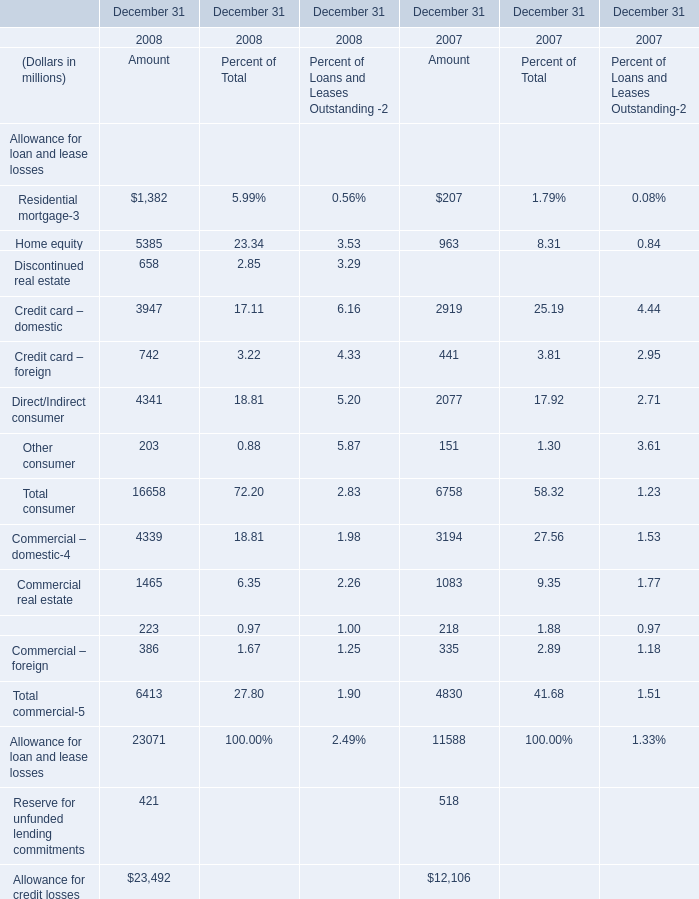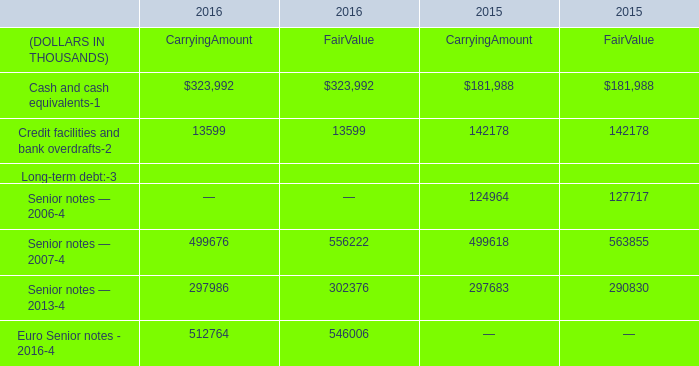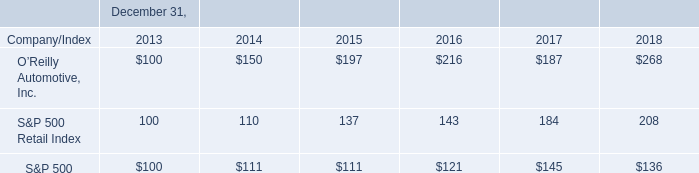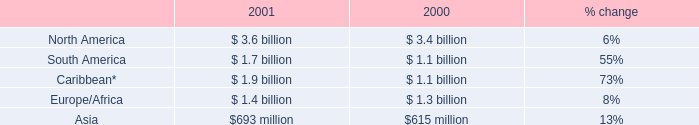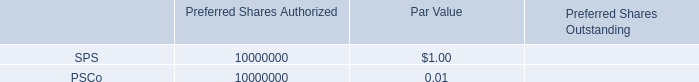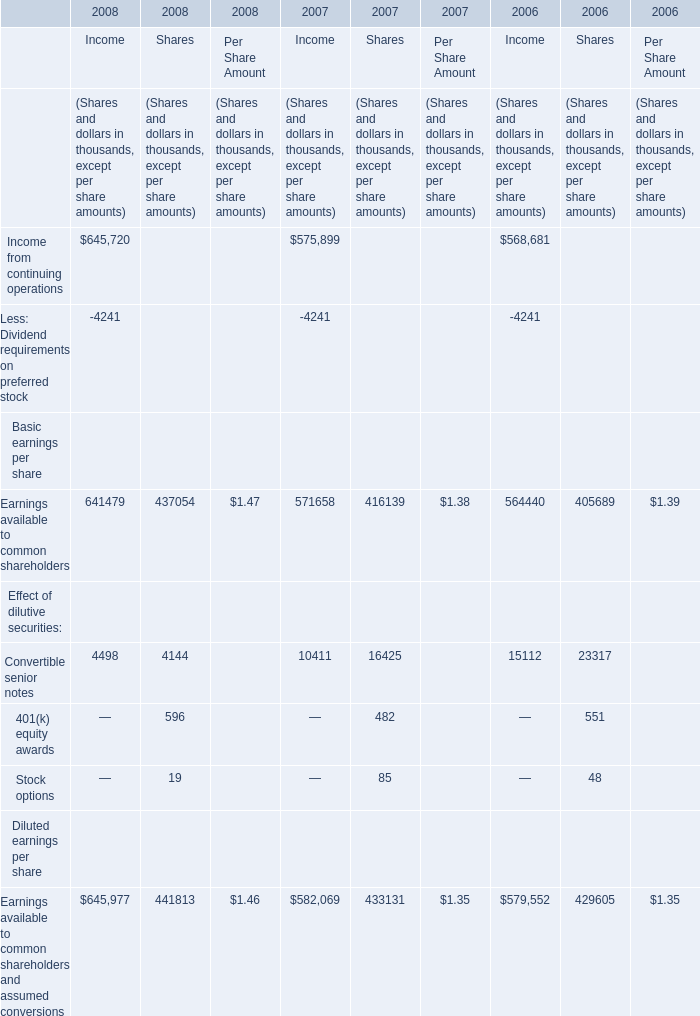What was the total amount of Income excluding those Income greater than 10000 in 2008? (in thousand) 
Computations: (-4241 + 4498)
Answer: 257.0. 